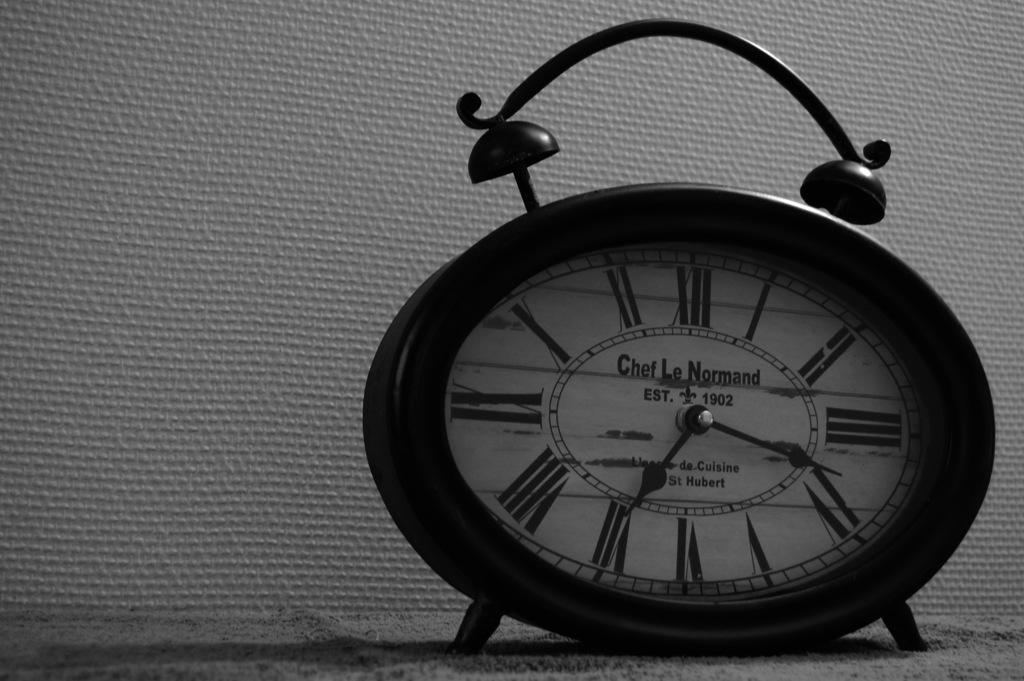<image>
Provide a brief description of the given image. An old style black alarm clock with roman numerals tells us it is almost 20 past 7. 